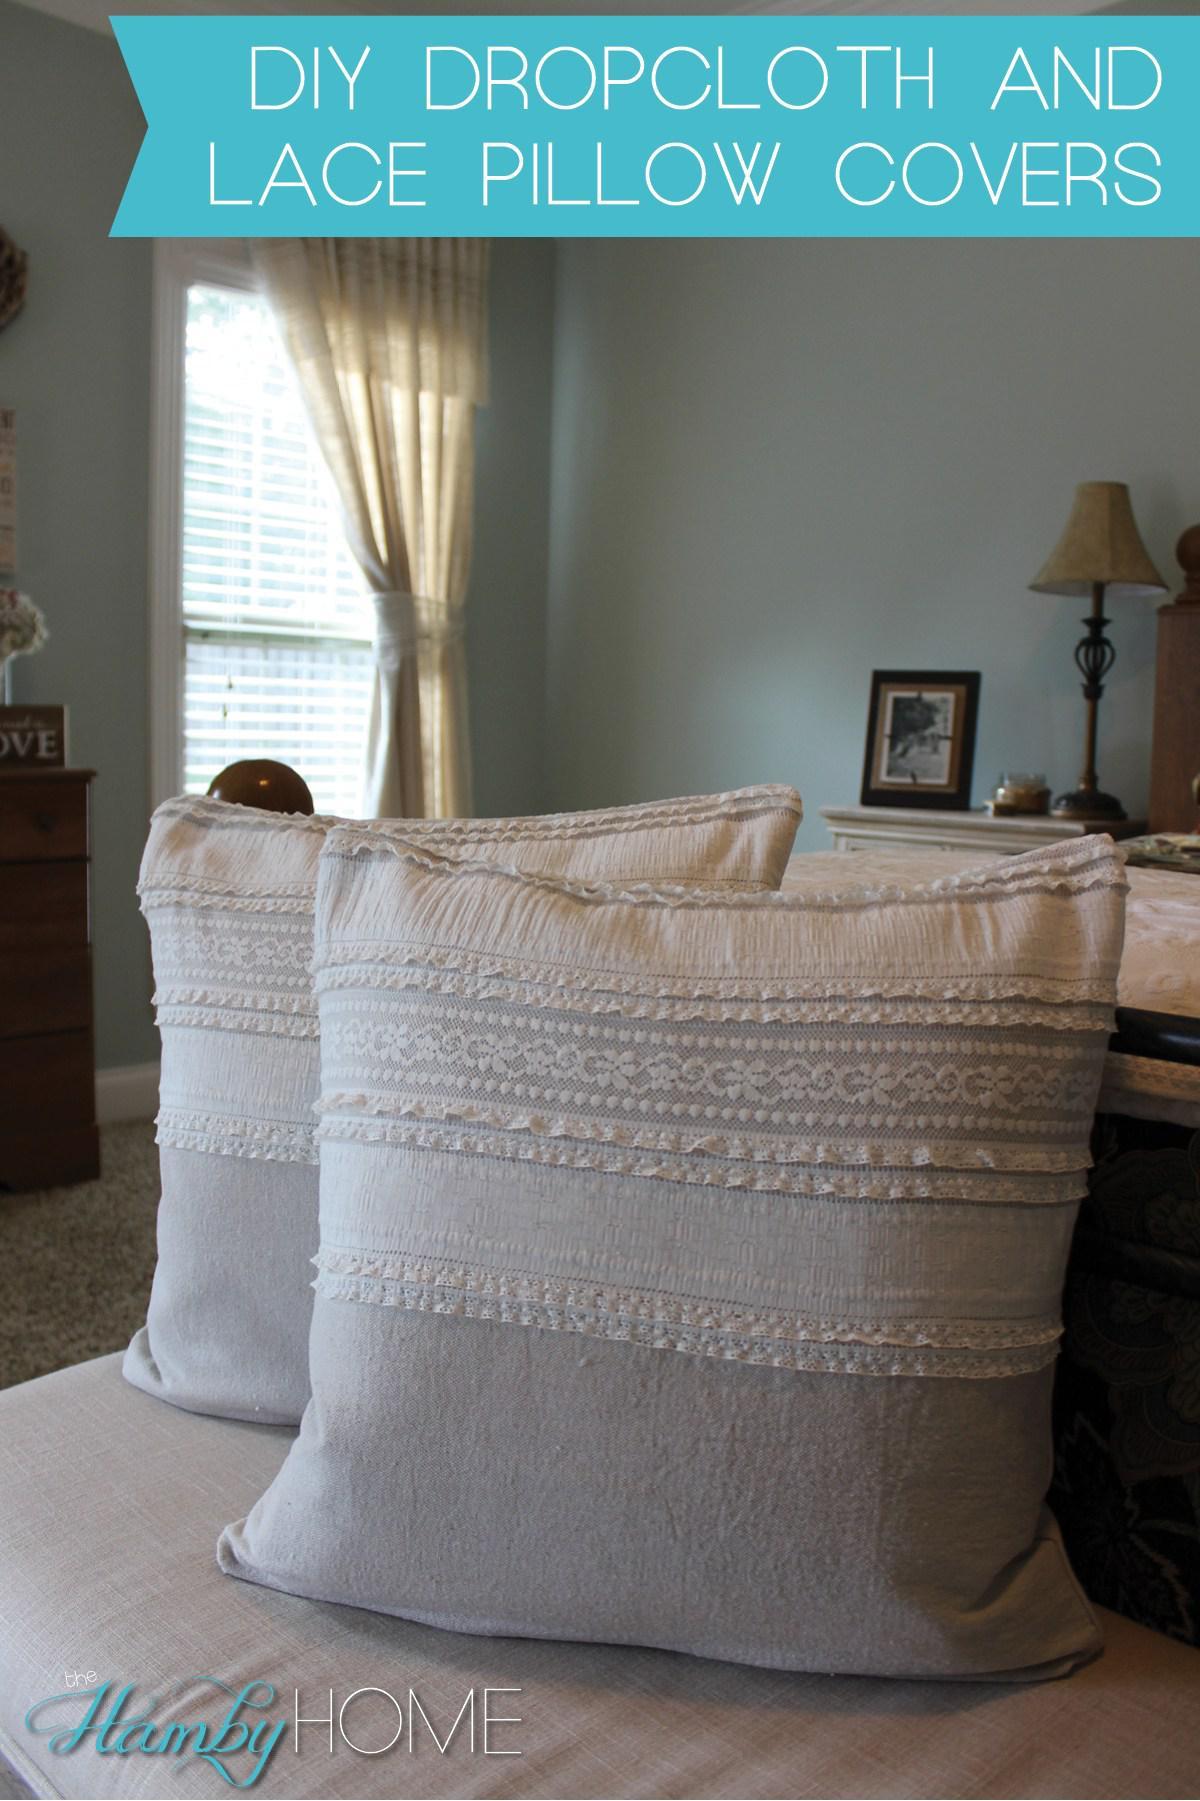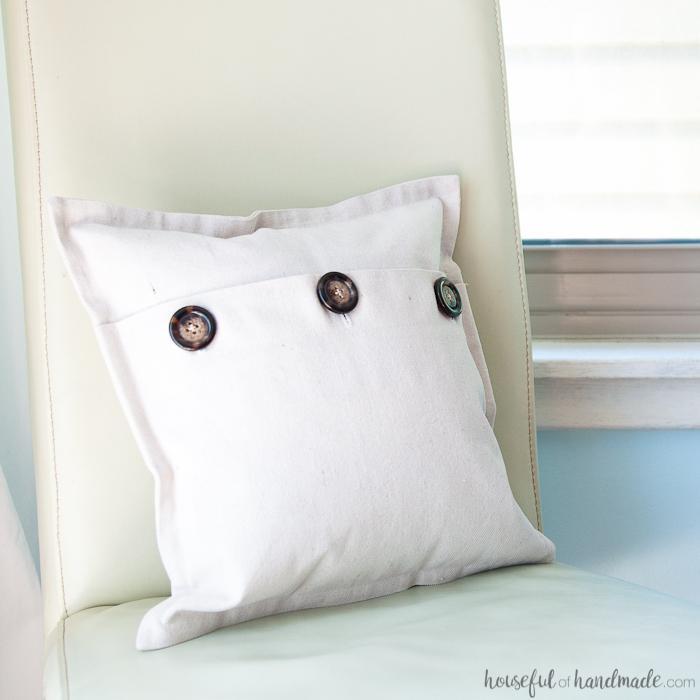The first image is the image on the left, the second image is the image on the right. Examine the images to the left and right. Is the description "The righthand image includes striped pillows and a pillow with mitten pairs stamped on it." accurate? Answer yes or no. No. The first image is the image on the left, the second image is the image on the right. Evaluate the accuracy of this statement regarding the images: "The right image contains at least four pillows.". Is it true? Answer yes or no. No. 